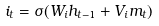Convert formula to latex. <formula><loc_0><loc_0><loc_500><loc_500>i _ { t } = \sigma ( W _ { i } h _ { t - 1 } + V _ { i } m _ { t } )</formula> 